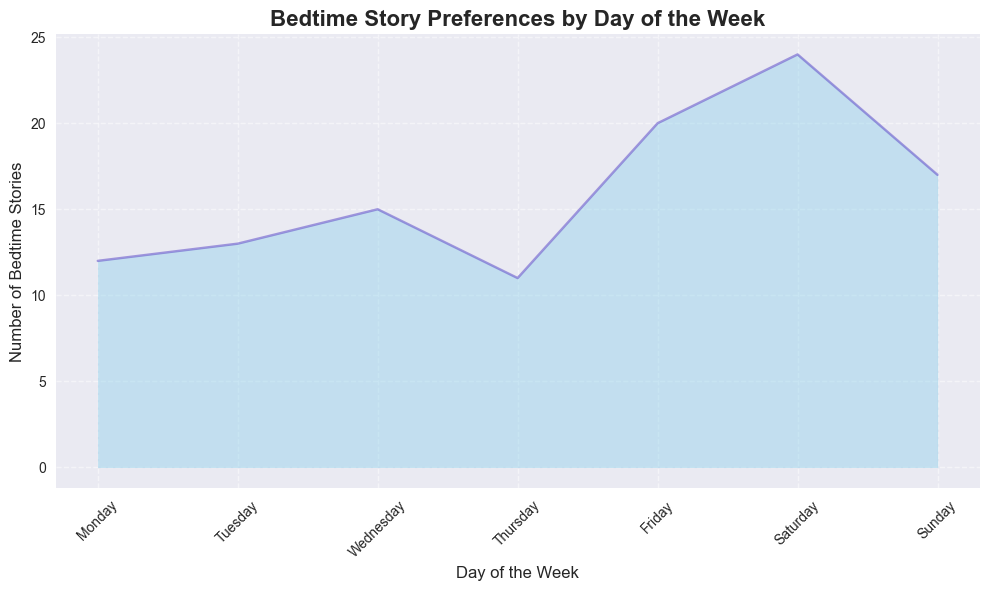Which day has the highest number of bedtime stories? By looking at the height of the filled area, we see that Saturday has the highest value.
Answer: Saturday Which day has the lowest number of bedtime stories? The lowest values are indicated by the smallest heights in the area plot, which is Thursday.
Answer: Thursday How many total bedtime stories are read on weekends (Saturday and Sunday) together? Saturday and Sunday have values of 24 (7+8+9) and 17 (5+6+6), respectively. Adding these numbers, 24 + 17 = 41.
Answer: 41 What is the difference in the number of bedtime stories between Monday and Friday? Summing for Monday (4+3+5=12) and Friday (6+7+7=20); 20 - 12 = 8
Answer: 8 What pattern can you observe in the number of bedtime stories as the week progresses? Generally, there's an increase in bedtime stories as we approach the weekend, peaking on Saturday, then slightly dropping on Sunday.
Answer: Increasing towards Saturday Which two consecutive days have the greatest difference in the number of bedtime stories? The biggest visual gap between two adjacent days is Saturday and Sunday, with a difference of 9 - 6 = 3.
Answer: Saturday and Sunday How do the number of bedtime stories on Sundays compare to Tuesdays? Summing up Sundays (5+6+6=17) and Tuesdays (3+4+6=13), Sundays have 4 more bedtime stories than Tuesdays.
Answer: Sundays have more What's the average number of bedtime stories per day during the week (Monday to Sunday)? Sum all the values (4+3+5+4+6+7+5+3+4+6+4+7+8+6+5+6+4+3+7+9+6=102) and divide by 7 days, so 102/7 ≈ 14.57
Answer: 14.57 What is the sum of the number of bedtime stories read on Wednesdays and Saturdays? Summing values for Wednesdays (5+6+4=15) and Saturdays (7+8+9=24), the total is 15+24=39.
Answer: 39 On which day does the number of bedtime stories first decrease compared to the previous day? By examining the visual plot, the first instance is Monday to Tuesday, with a drop from 4 to 3.
Answer: Tuesday 